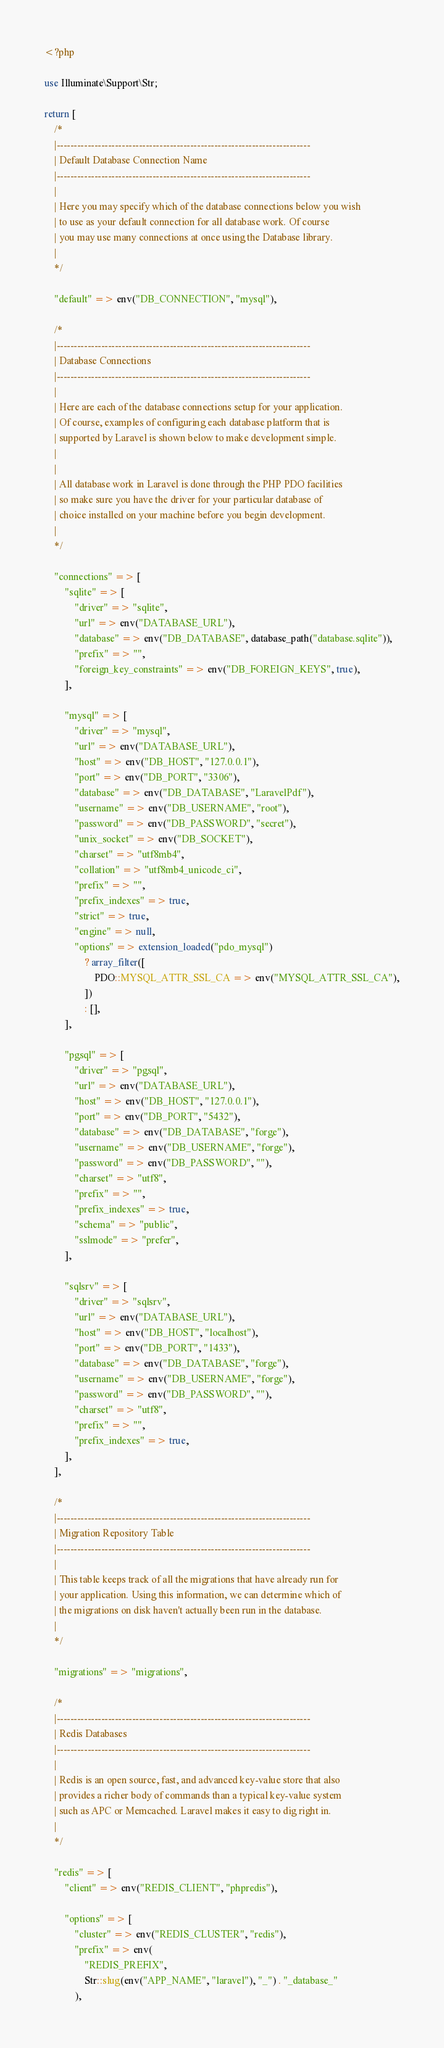<code> <loc_0><loc_0><loc_500><loc_500><_PHP_><?php

use Illuminate\Support\Str;

return [
    /*
    |--------------------------------------------------------------------------
    | Default Database Connection Name
    |--------------------------------------------------------------------------
    |
    | Here you may specify which of the database connections below you wish
    | to use as your default connection for all database work. Of course
    | you may use many connections at once using the Database library.
    |
    */

    "default" => env("DB_CONNECTION", "mysql"),

    /*
    |--------------------------------------------------------------------------
    | Database Connections
    |--------------------------------------------------------------------------
    |
    | Here are each of the database connections setup for your application.
    | Of course, examples of configuring each database platform that is
    | supported by Laravel is shown below to make development simple.
    |
    |
    | All database work in Laravel is done through the PHP PDO facilities
    | so make sure you have the driver for your particular database of
    | choice installed on your machine before you begin development.
    |
    */

    "connections" => [
        "sqlite" => [
            "driver" => "sqlite",
            "url" => env("DATABASE_URL"),
            "database" => env("DB_DATABASE", database_path("database.sqlite")),
            "prefix" => "",
            "foreign_key_constraints" => env("DB_FOREIGN_KEYS", true),
        ],

        "mysql" => [
            "driver" => "mysql",
            "url" => env("DATABASE_URL"),
            "host" => env("DB_HOST", "127.0.0.1"),
            "port" => env("DB_PORT", "3306"),
            "database" => env("DB_DATABASE", "LaravelPdf"),
            "username" => env("DB_USERNAME", "root"),
            "password" => env("DB_PASSWORD", "secret"),
            "unix_socket" => env("DB_SOCKET"),
            "charset" => "utf8mb4",
            "collation" => "utf8mb4_unicode_ci",
            "prefix" => "",
            "prefix_indexes" => true,
            "strict" => true,
            "engine" => null,
            "options" => extension_loaded("pdo_mysql")
                ? array_filter([
                    PDO::MYSQL_ATTR_SSL_CA => env("MYSQL_ATTR_SSL_CA"),
                ])
                : [],
        ],

        "pgsql" => [
            "driver" => "pgsql",
            "url" => env("DATABASE_URL"),
            "host" => env("DB_HOST", "127.0.0.1"),
            "port" => env("DB_PORT", "5432"),
            "database" => env("DB_DATABASE", "forge"),
            "username" => env("DB_USERNAME", "forge"),
            "password" => env("DB_PASSWORD", ""),
            "charset" => "utf8",
            "prefix" => "",
            "prefix_indexes" => true,
            "schema" => "public",
            "sslmode" => "prefer",
        ],

        "sqlsrv" => [
            "driver" => "sqlsrv",
            "url" => env("DATABASE_URL"),
            "host" => env("DB_HOST", "localhost"),
            "port" => env("DB_PORT", "1433"),
            "database" => env("DB_DATABASE", "forge"),
            "username" => env("DB_USERNAME", "forge"),
            "password" => env("DB_PASSWORD", ""),
            "charset" => "utf8",
            "prefix" => "",
            "prefix_indexes" => true,
        ],
    ],

    /*
    |--------------------------------------------------------------------------
    | Migration Repository Table
    |--------------------------------------------------------------------------
    |
    | This table keeps track of all the migrations that have already run for
    | your application. Using this information, we can determine which of
    | the migrations on disk haven't actually been run in the database.
    |
    */

    "migrations" => "migrations",

    /*
    |--------------------------------------------------------------------------
    | Redis Databases
    |--------------------------------------------------------------------------
    |
    | Redis is an open source, fast, and advanced key-value store that also
    | provides a richer body of commands than a typical key-value system
    | such as APC or Memcached. Laravel makes it easy to dig right in.
    |
    */

    "redis" => [
        "client" => env("REDIS_CLIENT", "phpredis"),

        "options" => [
            "cluster" => env("REDIS_CLUSTER", "redis"),
            "prefix" => env(
                "REDIS_PREFIX",
                Str::slug(env("APP_NAME", "laravel"), "_") . "_database_"
            ),</code> 